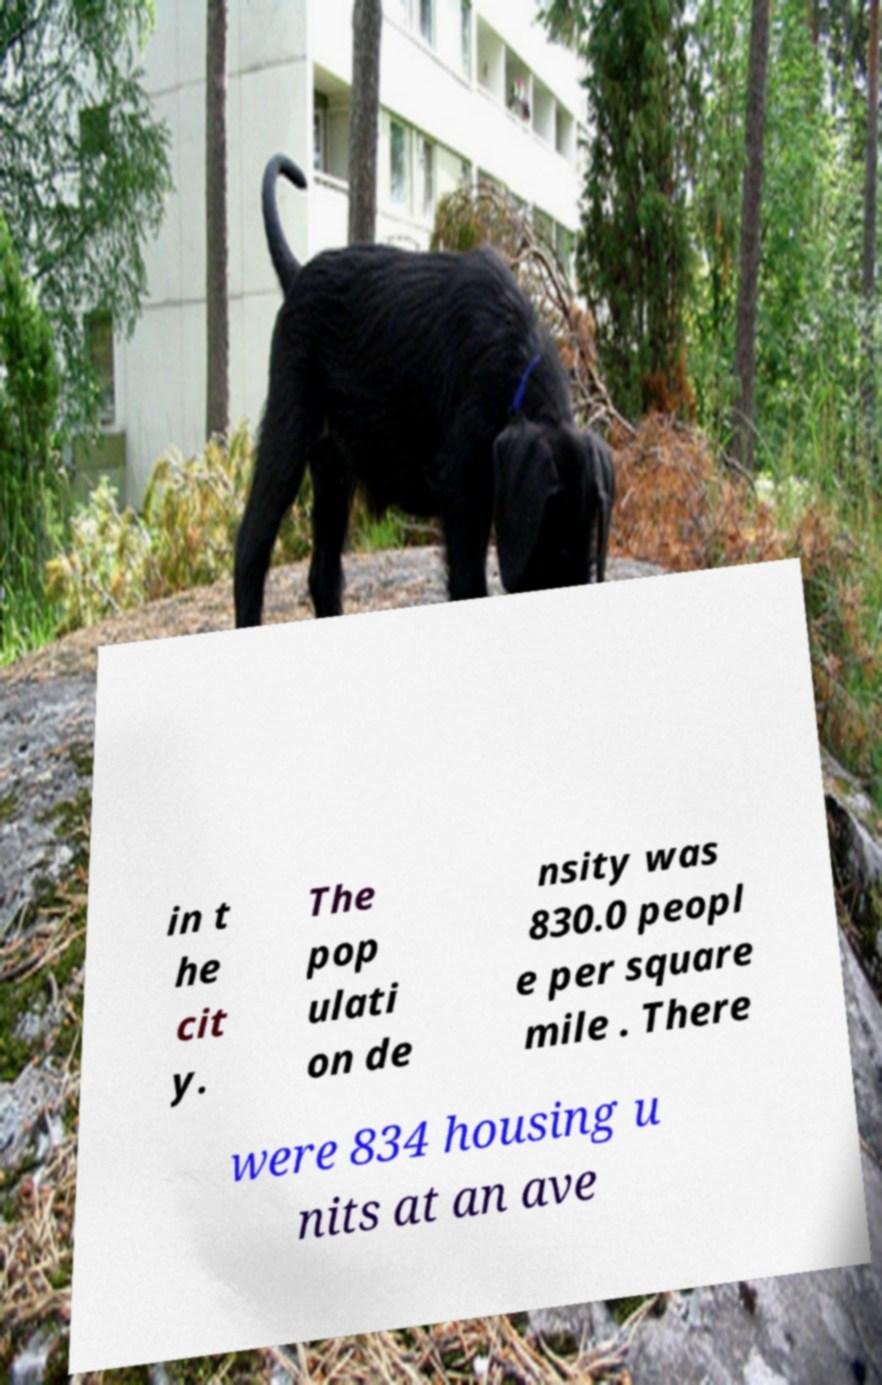Could you extract and type out the text from this image? in t he cit y. The pop ulati on de nsity was 830.0 peopl e per square mile . There were 834 housing u nits at an ave 